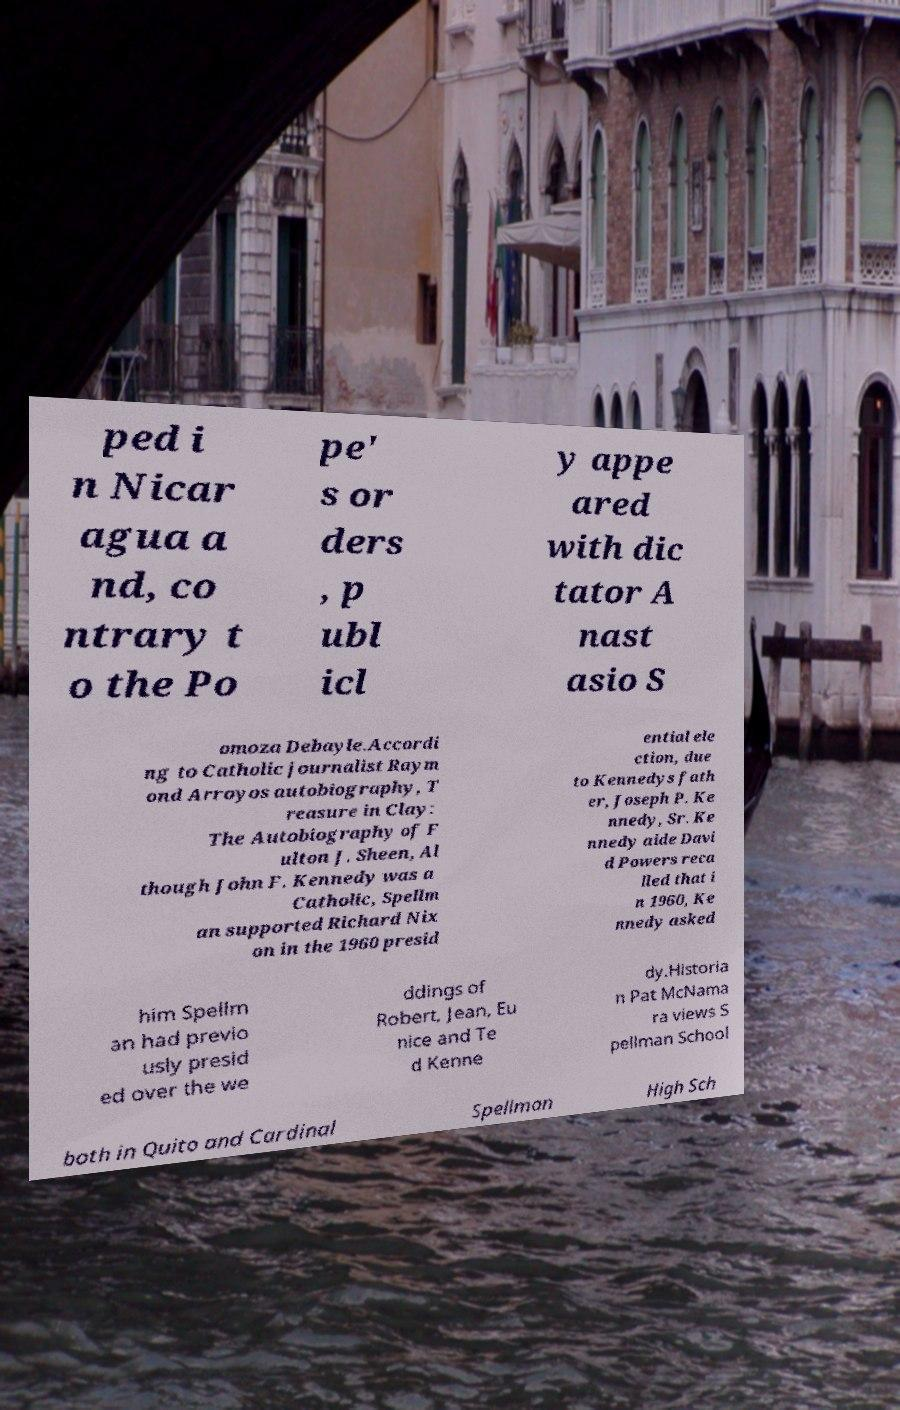Could you extract and type out the text from this image? ped i n Nicar agua a nd, co ntrary t o the Po pe' s or ders , p ubl icl y appe ared with dic tator A nast asio S omoza Debayle.Accordi ng to Catholic journalist Raym ond Arroyos autobiography, T reasure in Clay: The Autobiography of F ulton J. Sheen, Al though John F. Kennedy was a Catholic, Spellm an supported Richard Nix on in the 1960 presid ential ele ction, due to Kennedys fath er, Joseph P. Ke nnedy, Sr. Ke nnedy aide Davi d Powers reca lled that i n 1960, Ke nnedy asked him Spellm an had previo usly presid ed over the we ddings of Robert, Jean, Eu nice and Te d Kenne dy.Historia n Pat McNama ra views S pellman School both in Quito and Cardinal Spellman High Sch 